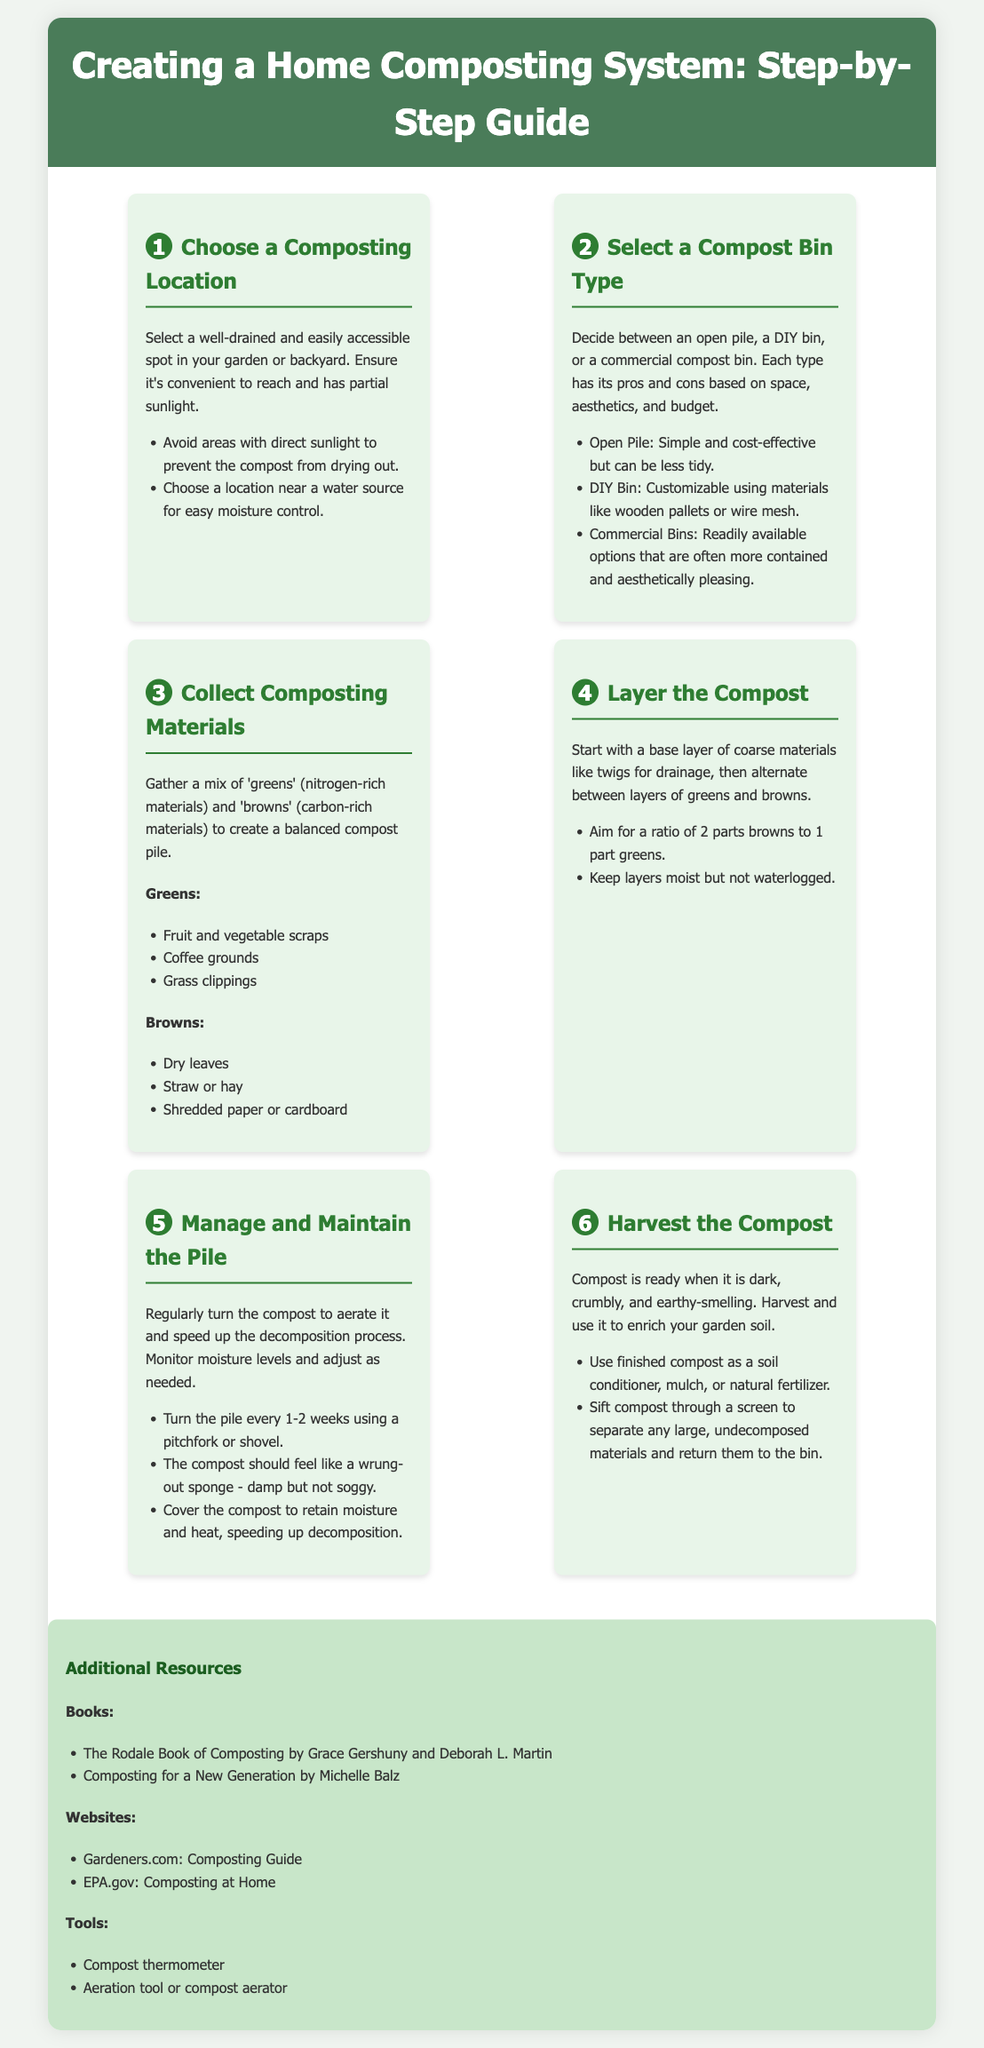What is the first step in creating a home composting system? The first step is to choose a composting location.
Answer: Choose a composting location What should be included in the composting materials? Composting materials should be a mix of 'greens' and 'browns.'
Answer: 'Greens' and 'browns' How often should the compost pile be turned? The compost pile should be turned every 1-2 weeks.
Answer: Every 1-2 weeks What is the ideal moisture level for compost? The compost should feel like a wrung-out sponge.
Answer: Like a wrung-out sponge What is the recommended ratio of browns to greens? The recommended ratio is 2 parts browns to 1 part greens.
Answer: 2 parts browns to 1 part greens What type of compost bin is customizable? A DIY bin is customizable.
Answer: DIY bin When is compost ready to be harvested? Compost is ready when it is dark, crumbly, and earthy-smelling.
Answer: Dark, crumbly, and earthy-smelling What resource is suggested for further reading? "The Rodale Book of Composting" is suggested for further reading.
Answer: The Rodale Book of Composting What should you do with large, undecomposed materials? Large, undecomposed materials should be returned to the bin.
Answer: Return them to the bin 